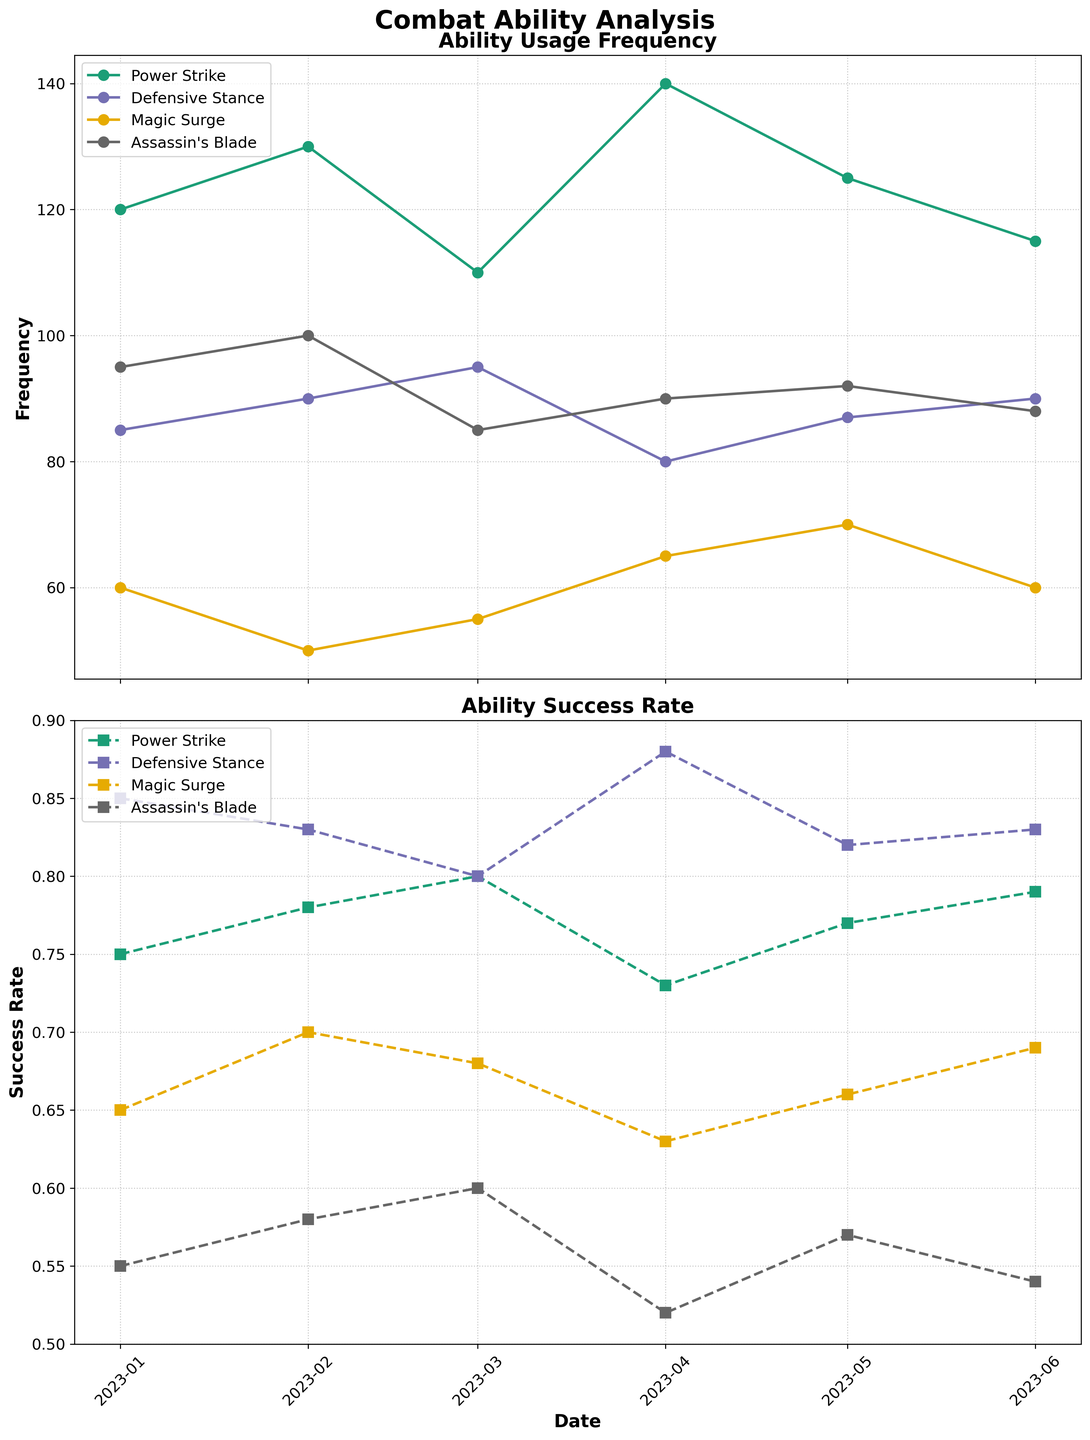What's the title of the figure? The title is displayed at the top of the figure and provides a summary of what the data represents. In this case, it is found at the top with a font size set to 20 and bold.
Answer: Combat Ability Analysis What abilities are tracked in the plot? The abilities are shown in the legend of the plot, which lists each ability represented by different colors.
Answer: Power Strike, Defensive Stance, Magic Surge, Assassin's Blade On which date did "Magic Surge" have its highest frequency of use? Look at the time series plot for "Magic Surge" in the "Ability Usage Frequency" chart. Identify the date with the highest point on that line.
Answer: 2023-05-01 Which ability had the highest success rate on 2023-04-01? Refer to the "Ability Success Rate" plot and identify the highest point among the abilities on the date 2023-04-01.
Answer: Defensive Stance How many data points are represented for each ability? Each ability has a time series line with data points at each date. Since the data spans from January to June and appears monthly, count the data points along a line.
Answer: 6 What is the average success rate for "Assassin's Blade" across all dates? Calculate the average by summing the success rates for each date and dividing by the number of dates. The rates are 0.55, 0.58, 0.60, 0.52, 0.57, and 0.54. (0.55 + 0.58 + 0.60 + 0.52 + 0.57 + 0.54) / 6 = 3.36 / 6
Answer: 0.56 Which ability had the largest drop in frequency from one month to the next? Compare the frequency changes between each consecutive month for each ability. Find the largest decrease by subtracting the frequencies and identifying the maximum negative change.
Answer: Assassin's Blade (March to April) How does the success rate of "Power Strike" in June compare with its success rate in January? Look at the "Power Strike" line in the "Ability Success Rate" plot and compare the values for January and June. January is 0.75 and June is 0.79.
Answer: Higher in June Across all abilities, what month had the highest average success rate? Calculate the average success rate for each month by summing the success rates for all abilities on that month and dividing by four (number of abilities). Compare these averages to find the highest. April's average is (0.73 + 0.88 + 0.63 + 0.52) / 4 = 0.69, which is the highest.
Answer: April Is there an ability whose success rate always increased or stayed the same over the periods shown? Look at each ability line in the "Ability Success Rate" plot to see if it never decreases from one month to the next.
Answer: No 